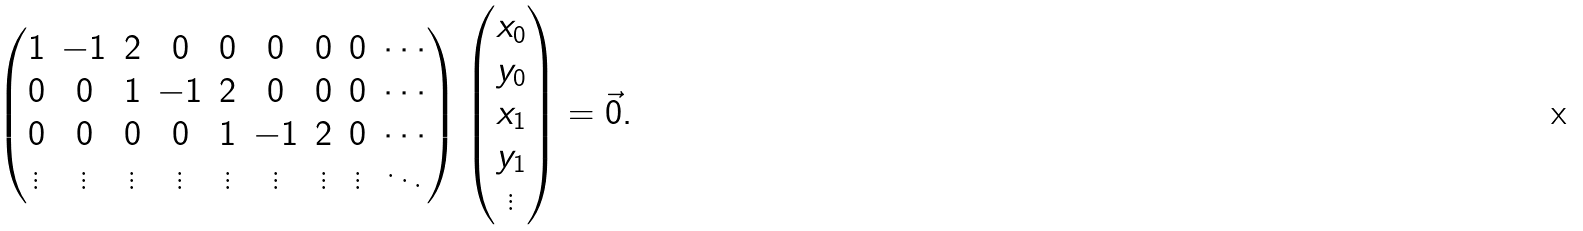<formula> <loc_0><loc_0><loc_500><loc_500>\begin{pmatrix} 1 & - 1 & 2 & 0 & 0 & 0 & 0 & 0 & \cdots \\ 0 & 0 & 1 & - 1 & 2 & 0 & 0 & 0 & \cdots \\ 0 & 0 & 0 & 0 & 1 & - 1 & 2 & 0 & \cdots \\ \vdots & \vdots & \vdots & \vdots & \vdots & \vdots & \vdots & \vdots & \ddots \end{pmatrix} \begin{pmatrix} x _ { 0 } \\ y _ { 0 } \\ x _ { 1 } \\ y _ { 1 } \\ \vdots \end{pmatrix} = \vec { 0 } .</formula> 